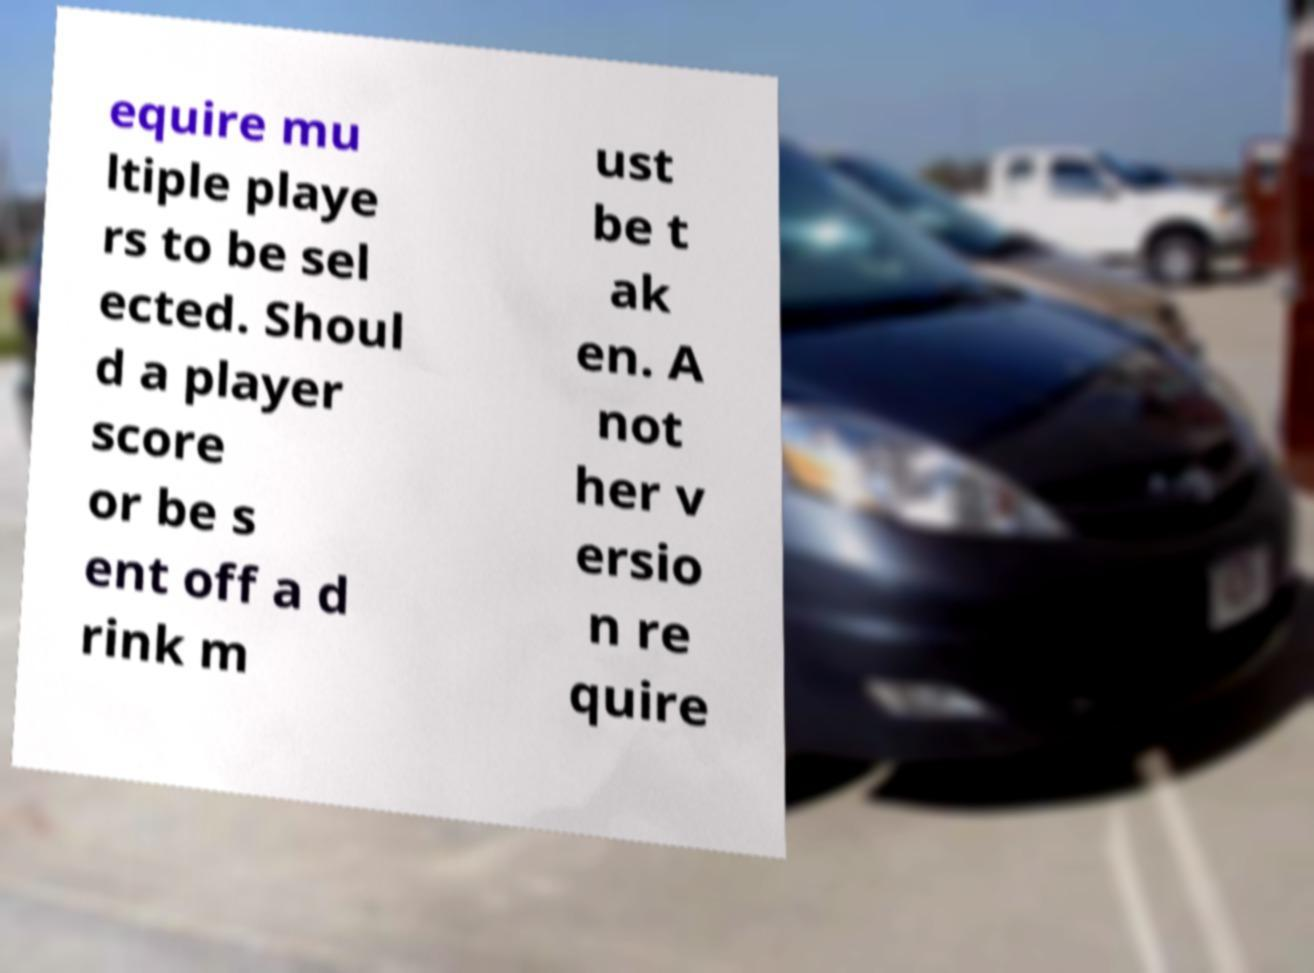What messages or text are displayed in this image? I need them in a readable, typed format. equire mu ltiple playe rs to be sel ected. Shoul d a player score or be s ent off a d rink m ust be t ak en. A not her v ersio n re quire 